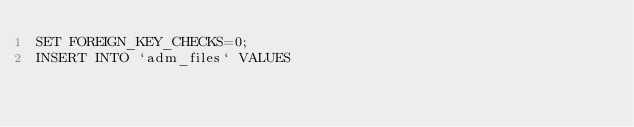<code> <loc_0><loc_0><loc_500><loc_500><_SQL_>SET FOREIGN_KEY_CHECKS=0;
INSERT INTO `adm_files` VALUES </code> 